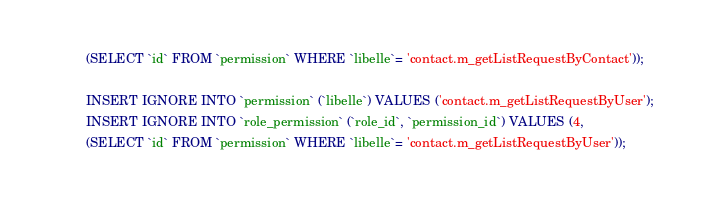<code> <loc_0><loc_0><loc_500><loc_500><_SQL_>(SELECT `id` FROM `permission` WHERE `libelle`= 'contact.m_getListRequestByContact'));

INSERT IGNORE INTO `permission` (`libelle`) VALUES ('contact.m_getListRequestByUser');
INSERT IGNORE INTO `role_permission` (`role_id`, `permission_id`) VALUES (4, 
(SELECT `id` FROM `permission` WHERE `libelle`= 'contact.m_getListRequestByUser'));</code> 